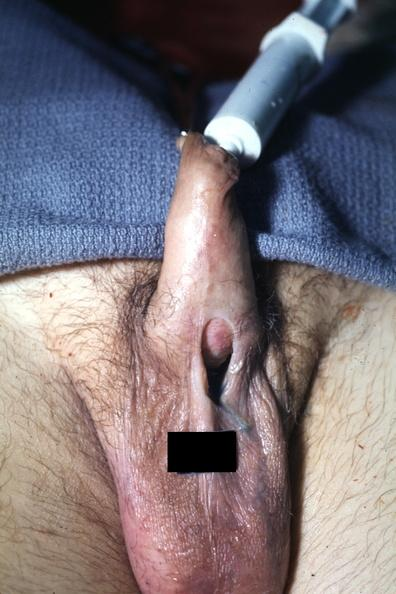s this cells present?
Answer the question using a single word or phrase. No 